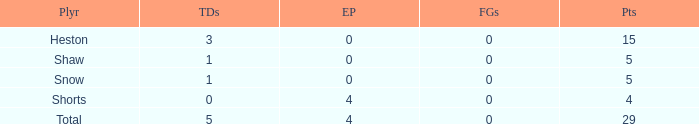What is the total number of field goals for a player that had less than 3 touchdowns, had 4 points, and had less than 4 extra points? 0.0. 